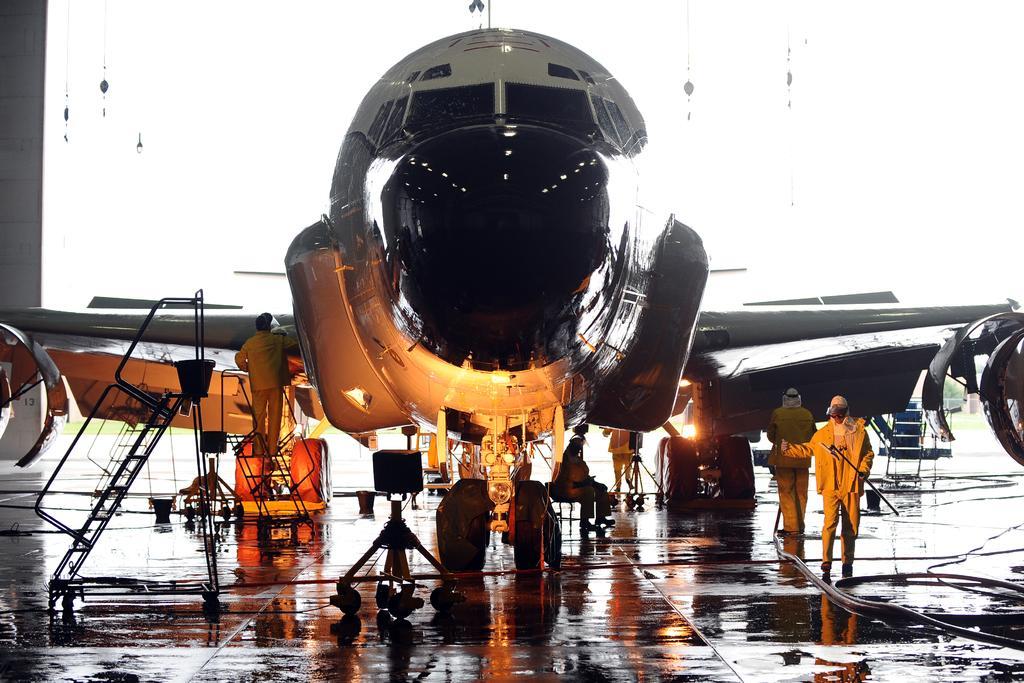Can you describe this image briefly? In this image I can see an aircraft. To the side of an aircraft I can see few people. To the left I can see the ladder and there are some pipes on the floor. And there is a white background. 